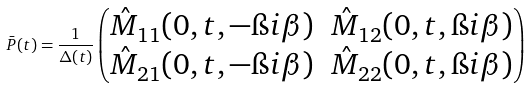<formula> <loc_0><loc_0><loc_500><loc_500>\bar { P } ( t ) = \frac { 1 } { \Delta ( t ) } \begin{pmatrix} \hat { M } _ { 1 1 } ( 0 , t , - \i i \beta ) & \hat { M } _ { 1 2 } ( 0 , t , \i i \beta ) \\ \hat { M } _ { 2 1 } ( 0 , t , - \i i \beta ) & \hat { M } _ { 2 2 } ( 0 , t , \i i \beta ) \end{pmatrix}</formula> 